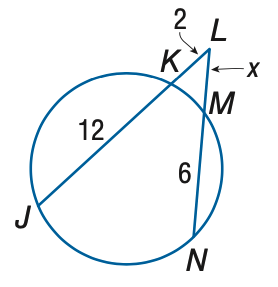Question: Find x to the nearest tenth.
Choices:
A. 2.1
B. 2.6
C. 3.1
D. 3.6
Answer with the letter. Answer: C 